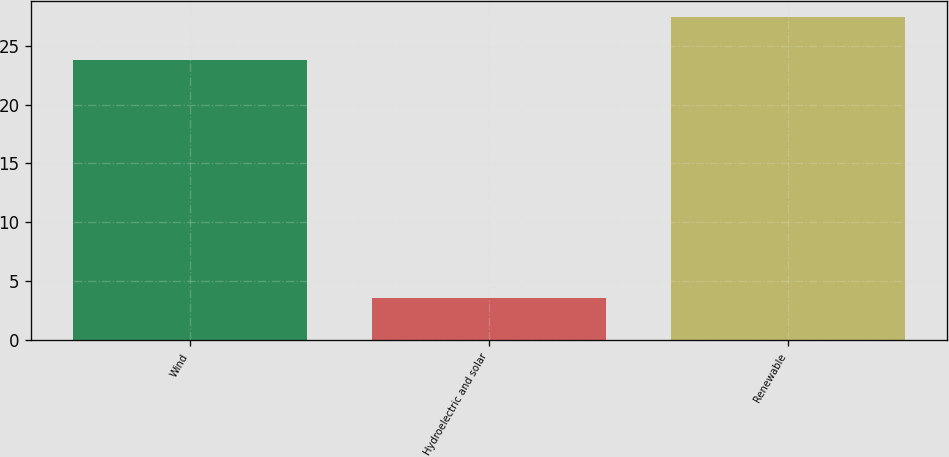<chart> <loc_0><loc_0><loc_500><loc_500><bar_chart><fcel>Wind<fcel>Hydroelectric and solar<fcel>Renewable<nl><fcel>23.8<fcel>3.6<fcel>27.4<nl></chart> 